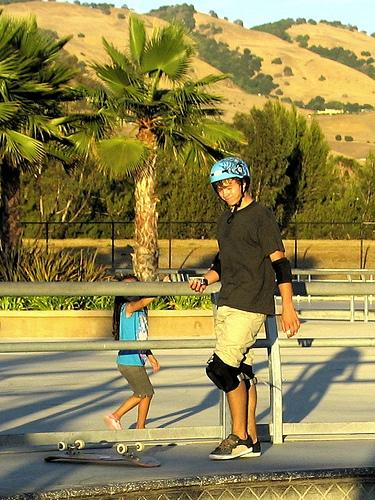What kind of palm tree is in the center of this photo?

Choices:
A) queen palm
B) fishtail palm
C) fan palm
D) sago palm fan palm 